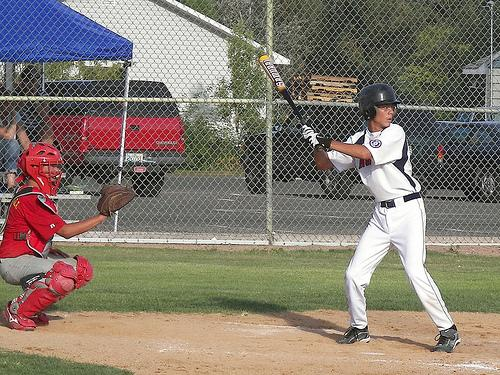Articulate the principal event transpiring in the image. Amidst an exciting baseball game, a batter clad in white and a catcher wearing red gear engage in a crucial play. Express the chief incident happening in the snapshot. An intense baseball play unfolds as a batter readies his swing and the catcher, in full protective garb, waits attentively behind him. Illustrate the central subject in the image and their actions. A baseball batter wearing a black helmet swings his bat, while the catcher decked in protective gear awaits the pitch behind him. Create a brief description of the central action occurring in the image. A batter swings a baseball bat while a catcher waits behind him, both wearing their respective protective gear. Draft a succinct account of the primary activity depicted in the image. A baseball player swings his bat as the catcher, equipped with protective gear, waits to catch the incoming ball. Provide a concise overview of the main events in the picture. A baseball game is in progress as the batter, wearing a black helmet, swings for the ball while the catcher, in a red helmet, stands ready. Narrate what's happening between the two main characters in the image. In a tense moment, a batter prepares to hit the ball while the catcher, fully geared up, anticipates the incoming pitch. Summarize the primary scene displayed in the photo. A baseball player attempts to hit a pitch while a catcher is at the ready, and people are watching the game from the stands. Explain the core scenario exhibited in the photo. The photo showcases a thrilling baseball match, with a batter swinging and a catcher set to catch, as spectators watch from the stands. Outline the key occurrence taking place in the photograph. A baseball batter, donning a black helmet, is swinging his bat while the catcher, clad in red safety gear, prepares to catch the ball. 